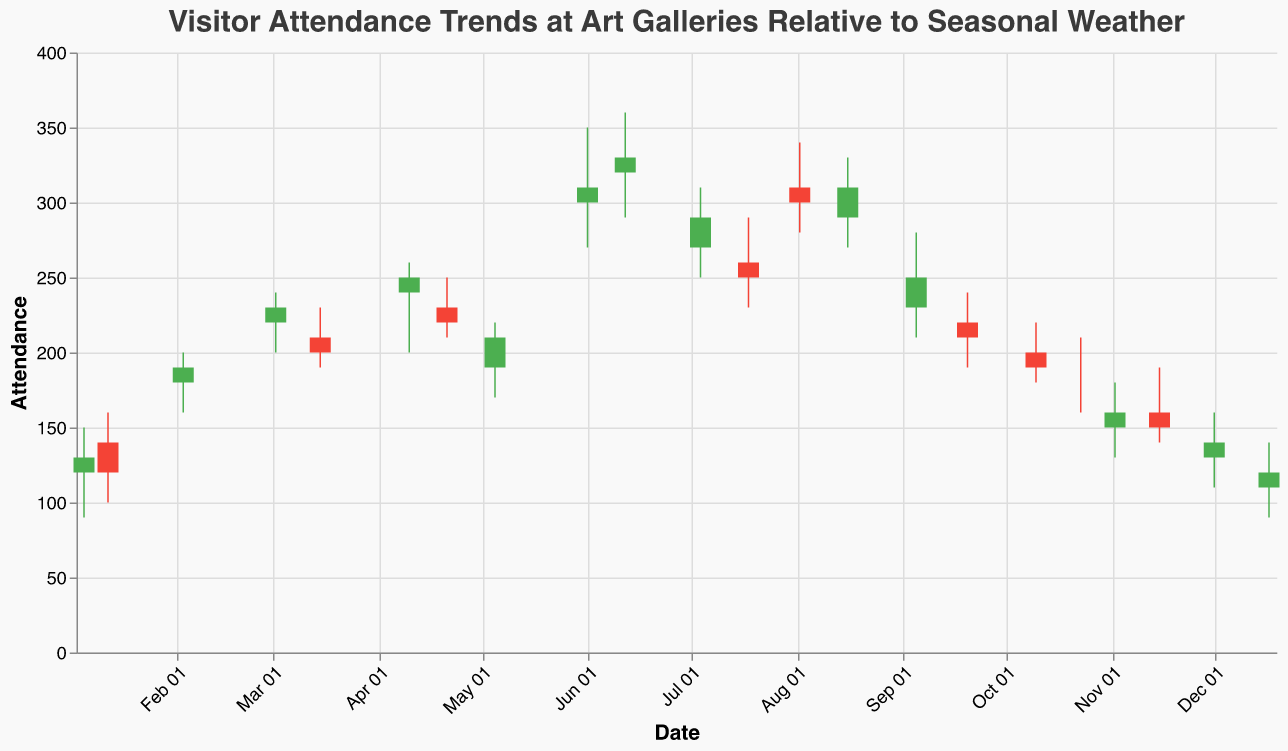What is the title of the plot? The title of the plot appears at the top and summarizes the main focus of the visualization, which is about visitor attendance trends relative to seasonal weather conditions.
Answer: Visitor Attendance Trends at Art Galleries Relative to Seasonal Weather What are the names of the x-axis and y-axis? The x-axis represents 'Date' while the y-axis represents 'Attendance'. The axes are visually labeled with these titles.
Answer: Date and Attendance On which date was the highest attendance recorded in the dataset? By examining the highs for each date, the highest attendance was recorded on 2023-06-12 with a high of 360.
Answer: 2023-06-12 How does attendance vary between Snow and Clear weather? By comparing attendance data points, Snow days tend to have lower attendance, e.g., 2023-01-05 (High: 150) and 2023-12-17 (High: 140), whereas Clear days show higher attendances, e.g., 2023-06-01 (High: 350) and 2023-07-18 (High: 290).
Answer: Lower during Snow, higher during Clear Based on the plot, which weather condition seems to be associated with the highest attendance? Clear weather conditions are associated with higher attendance levels, as indicated by the higher peaks on dates with clear weather. The high attendance on 2023-06-01 and 2023-06-12 both fall under clear weather.
Answer: Clear Calculate the average high attendance for the months of March, April, May, and June. To find the average, sum the high attendances for the months in question and divide by the number of data points: [(240+230)+(260+250)+(220)+(350+360)] / 8 = 2410 / 8 = 301.25
Answer: 301.25 Compare the attendance (Closing) on 2023-12-17 and 2023-01-05. Which one is higher? By comparing the closing attendance values, 2023-01-05 has a higher closing attendance (130) than 2023-12-17 (120).
Answer: 2023-01-05 Identify any date where the Close Attendance is equal to the Open Attendance. By examining the bars in the plot, 2023-10-23 shows close attendance equal to open attendance.
Answer: 2023-10-23 Which date in August had a higher attendance, the 2nd or the 16th? By comparing the attendance data for August, the 16th closed at 310 while the 2nd closed at 300, making the 16th the higher attendance date.
Answer: August 16 How many days had a Low Attendance of 150 or less? By counting the bars where the low attendance dips to 150 or below: 2023-01-05, 2023-01-12, 2023-11-02, 2023-12-01, 2023-12-17. That's 5 dates.
Answer: 5 